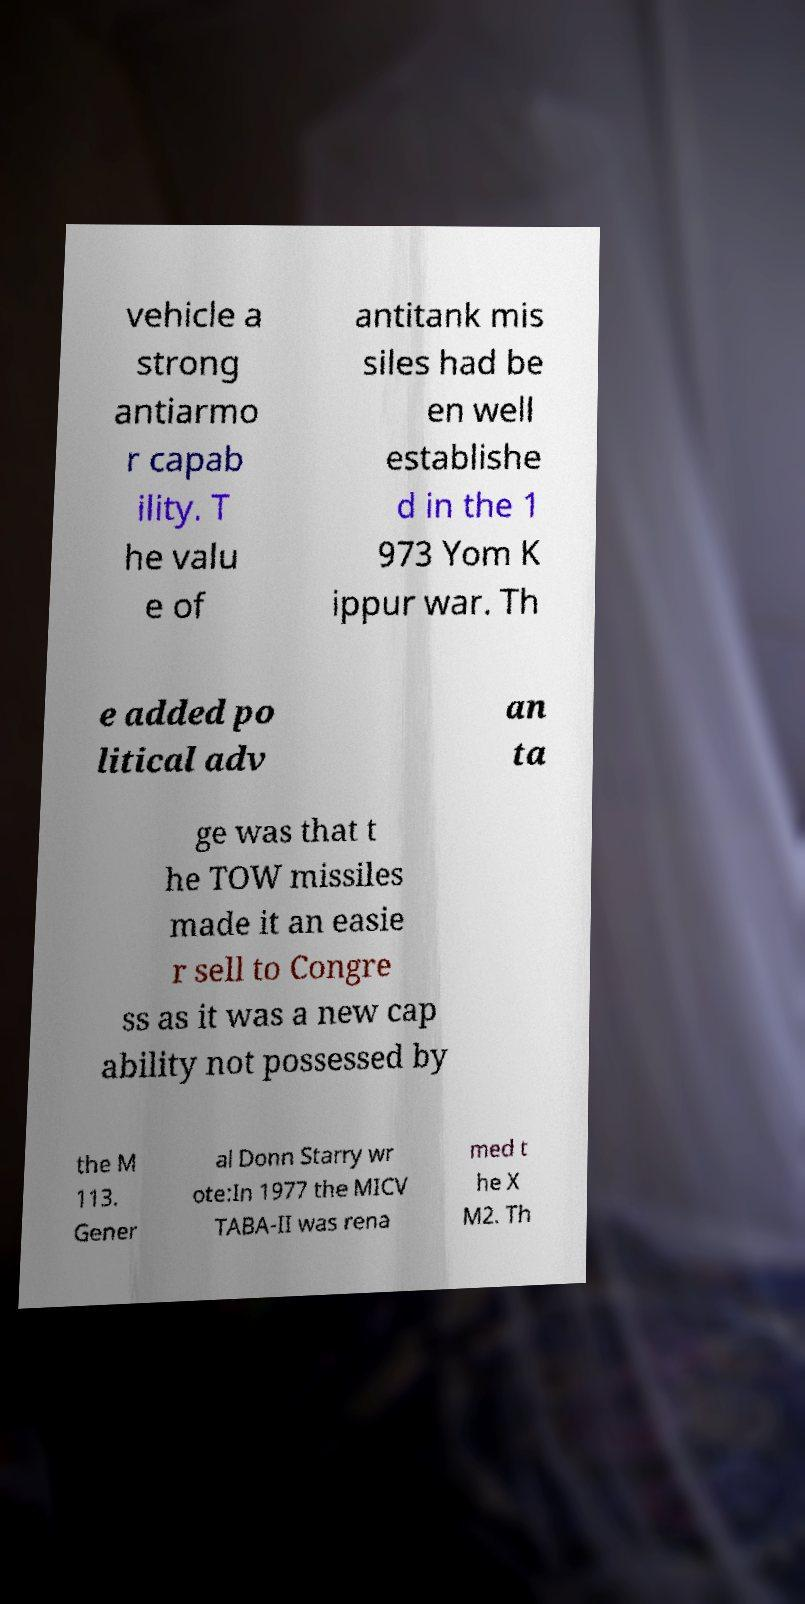Could you assist in decoding the text presented in this image and type it out clearly? vehicle a strong antiarmo r capab ility. T he valu e of antitank mis siles had be en well establishe d in the 1 973 Yom K ippur war. Th e added po litical adv an ta ge was that t he TOW missiles made it an easie r sell to Congre ss as it was a new cap ability not possessed by the M 113. Gener al Donn Starry wr ote:In 1977 the MICV TABA-II was rena med t he X M2. Th 